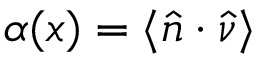<formula> <loc_0><loc_0><loc_500><loc_500>\alpha ( x ) = \langle \hat { n } \cdot \hat { \nu } \rangle</formula> 